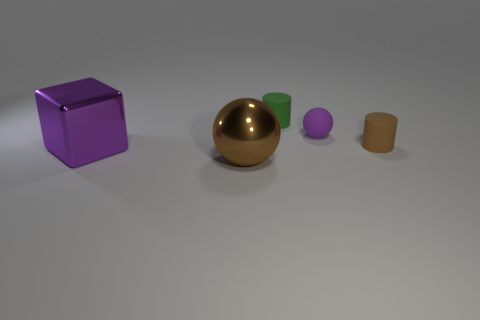Add 2 small brown shiny cubes. How many objects exist? 7 Subtract all blocks. How many objects are left? 4 Add 3 brown matte objects. How many brown matte objects exist? 4 Subtract 1 brown spheres. How many objects are left? 4 Subtract all tiny purple matte spheres. Subtract all small rubber things. How many objects are left? 1 Add 1 purple spheres. How many purple spheres are left? 2 